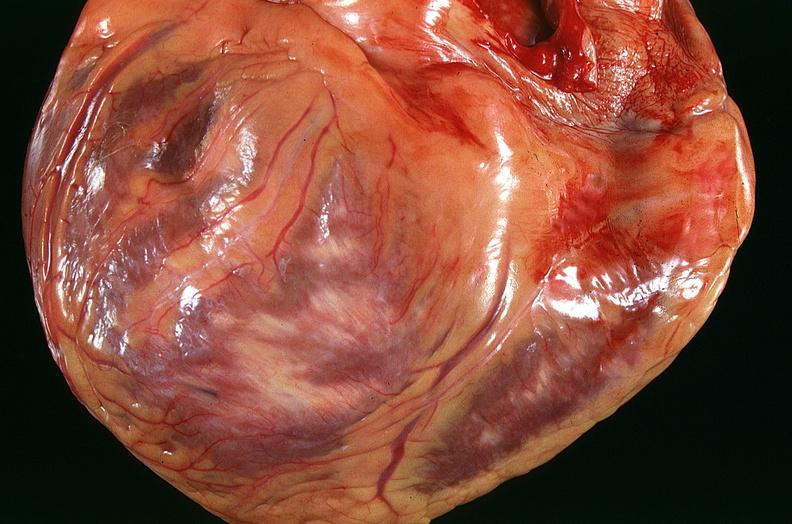what does this image show?
Answer the question using a single word or phrase. Congestive heart failure 